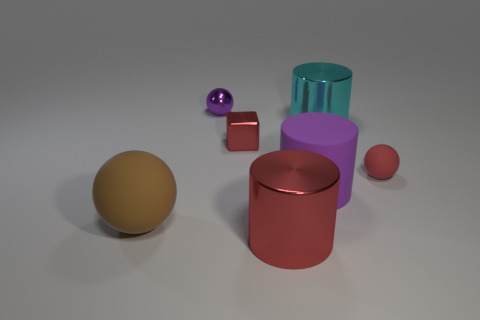Can you describe the sphere in the image? Certainly! The sphere in the image has a reflective, gold-like surface, providing a sense of its smooth texture. It's positioned on the left side and it's relatively large compared to the other objects. 